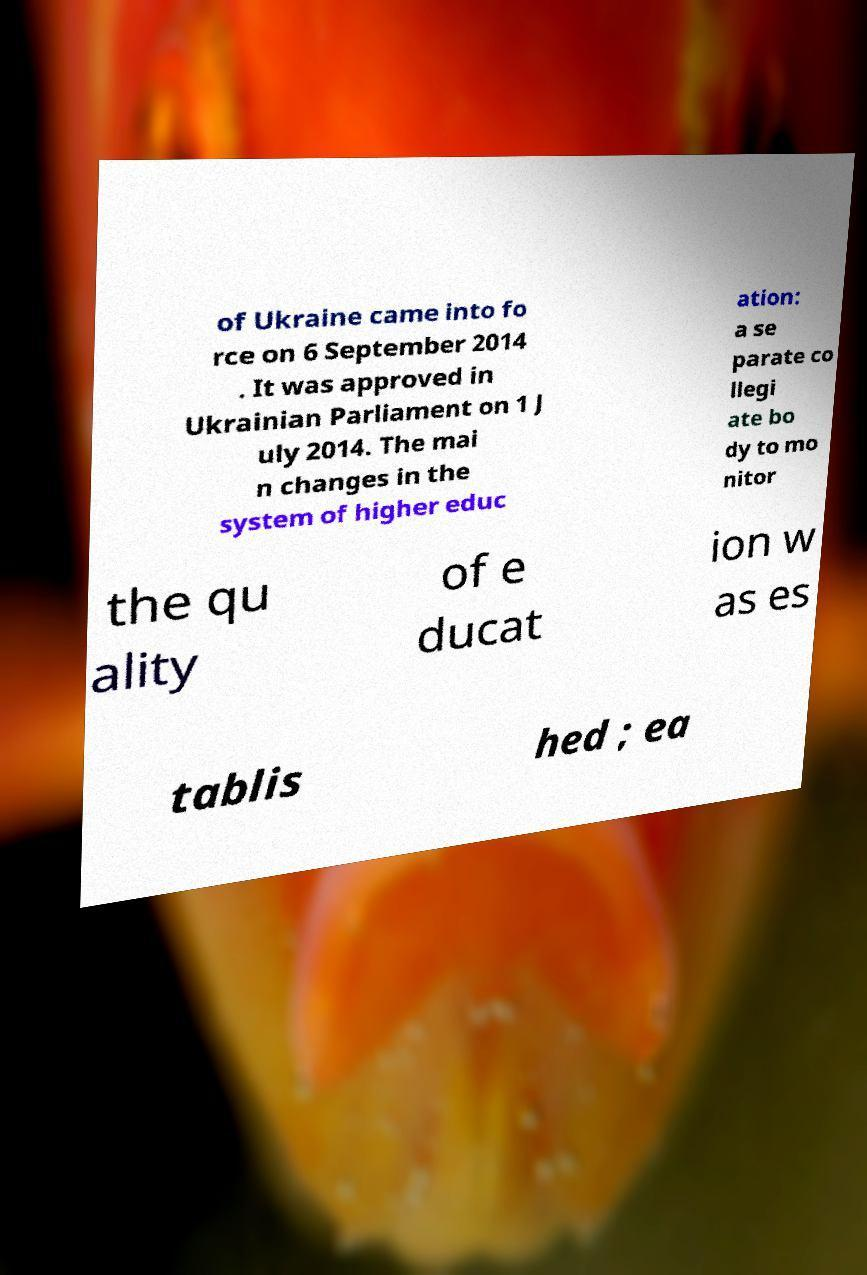For documentation purposes, I need the text within this image transcribed. Could you provide that? of Ukraine came into fo rce on 6 September 2014 . It was approved in Ukrainian Parliament on 1 J uly 2014. The mai n changes in the system of higher educ ation: a se parate co llegi ate bo dy to mo nitor the qu ality of e ducat ion w as es tablis hed ; ea 